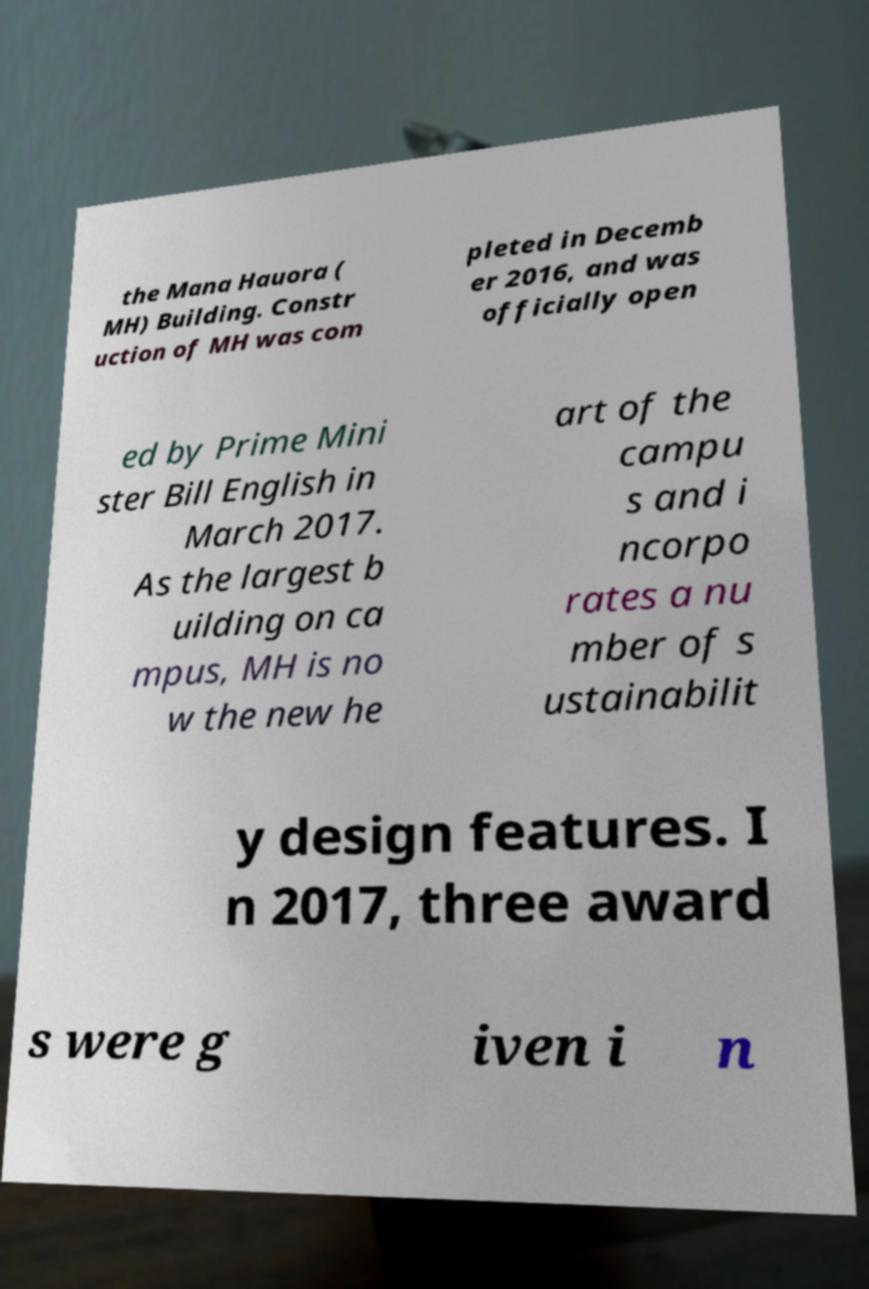Could you extract and type out the text from this image? the Mana Hauora ( MH) Building. Constr uction of MH was com pleted in Decemb er 2016, and was officially open ed by Prime Mini ster Bill English in March 2017. As the largest b uilding on ca mpus, MH is no w the new he art of the campu s and i ncorpo rates a nu mber of s ustainabilit y design features. I n 2017, three award s were g iven i n 